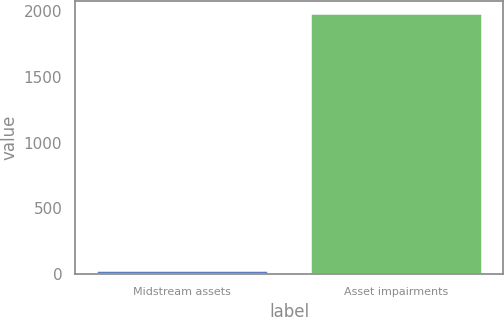Convert chart. <chart><loc_0><loc_0><loc_500><loc_500><bar_chart><fcel>Midstream assets<fcel>Asset impairments<nl><fcel>23<fcel>1976<nl></chart> 